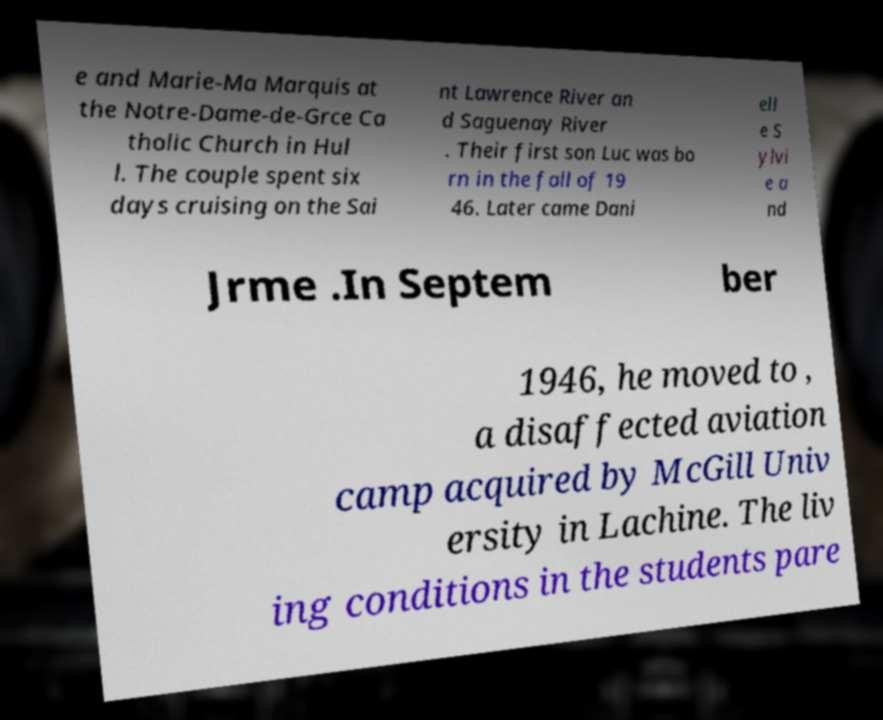Could you assist in decoding the text presented in this image and type it out clearly? e and Marie-Ma Marquis at the Notre-Dame-de-Grce Ca tholic Church in Hul l. The couple spent six days cruising on the Sai nt Lawrence River an d Saguenay River . Their first son Luc was bo rn in the fall of 19 46. Later came Dani ell e S ylvi e a nd Jrme .In Septem ber 1946, he moved to , a disaffected aviation camp acquired by McGill Univ ersity in Lachine. The liv ing conditions in the students pare 